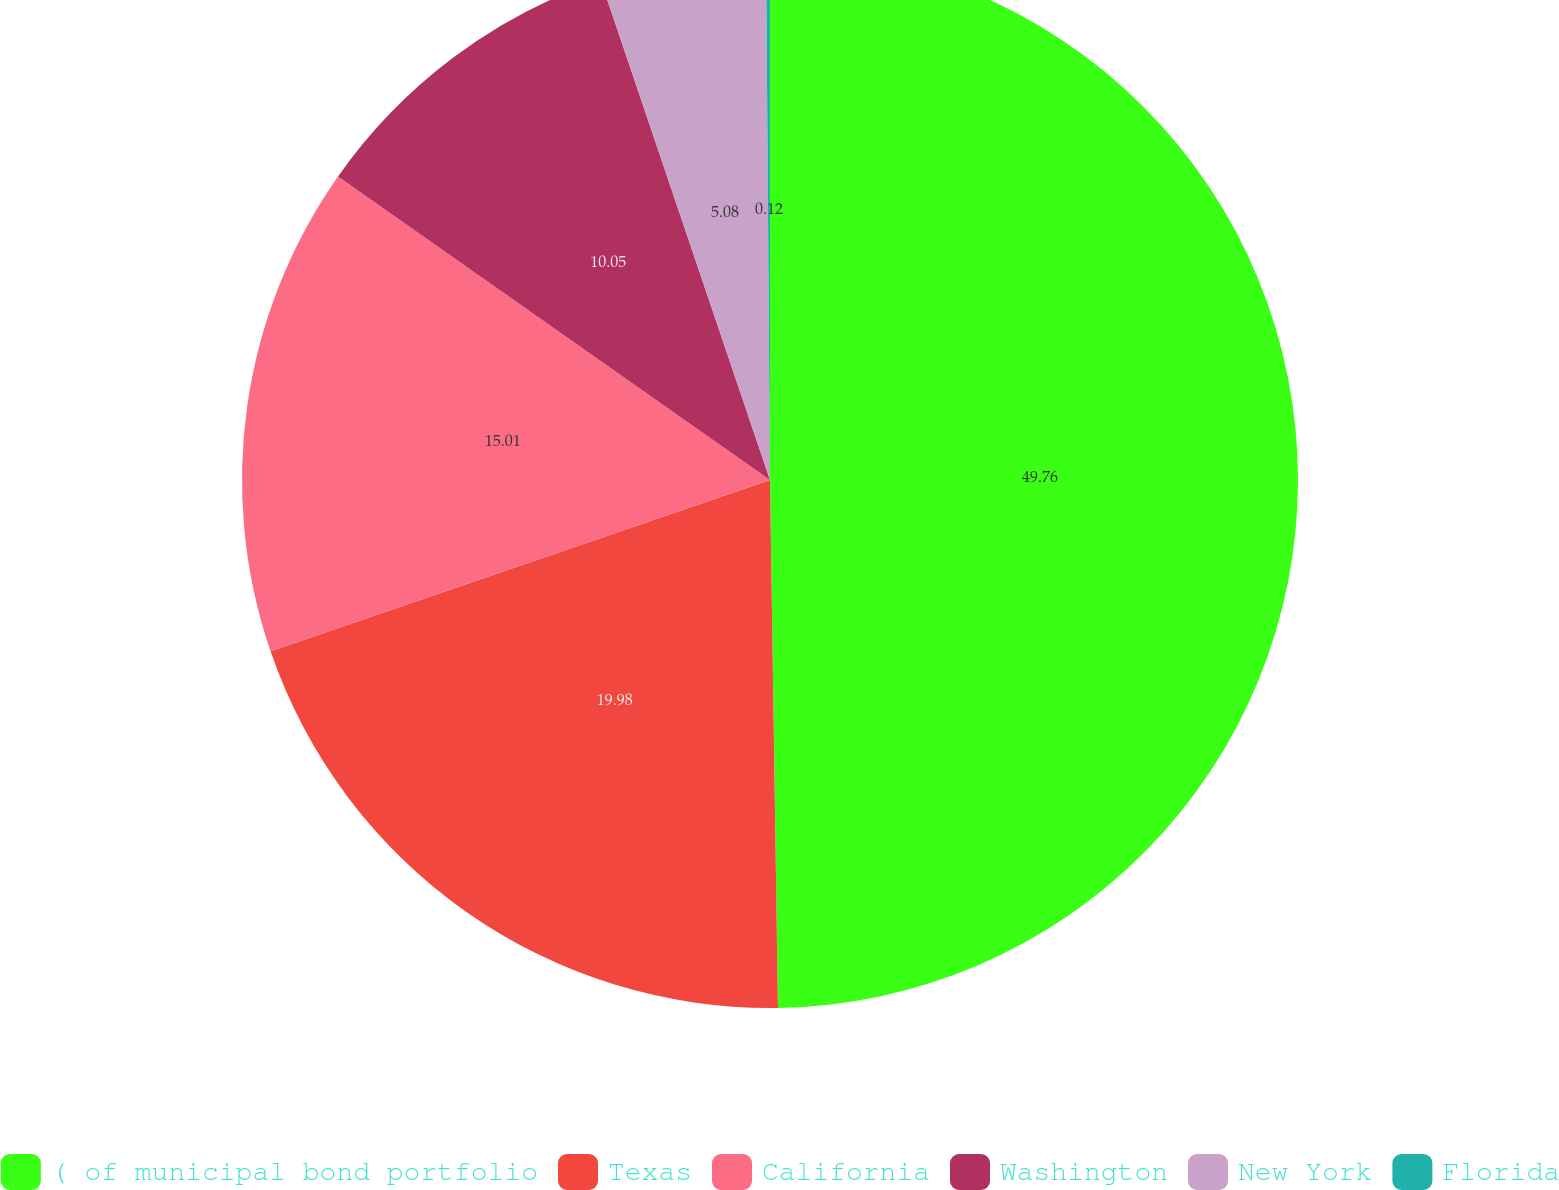<chart> <loc_0><loc_0><loc_500><loc_500><pie_chart><fcel>( of municipal bond portfolio<fcel>Texas<fcel>California<fcel>Washington<fcel>New York<fcel>Florida<nl><fcel>49.76%<fcel>19.98%<fcel>15.01%<fcel>10.05%<fcel>5.08%<fcel>0.12%<nl></chart> 